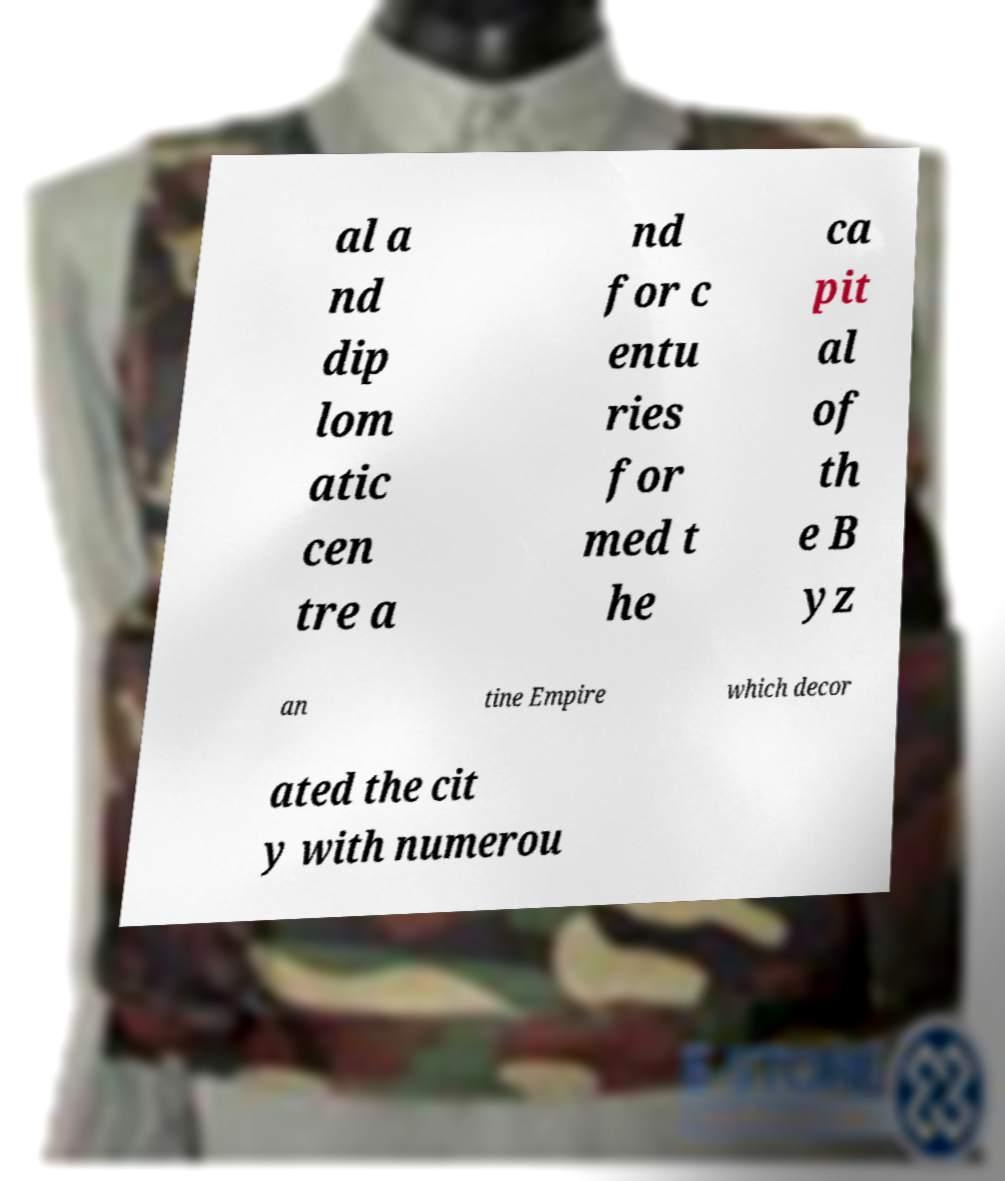Could you assist in decoding the text presented in this image and type it out clearly? al a nd dip lom atic cen tre a nd for c entu ries for med t he ca pit al of th e B yz an tine Empire which decor ated the cit y with numerou 